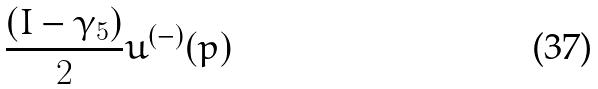Convert formula to latex. <formula><loc_0><loc_0><loc_500><loc_500>\frac { ( I - \gamma _ { 5 } ) } { 2 } u ^ { ( - ) } ( p )</formula> 